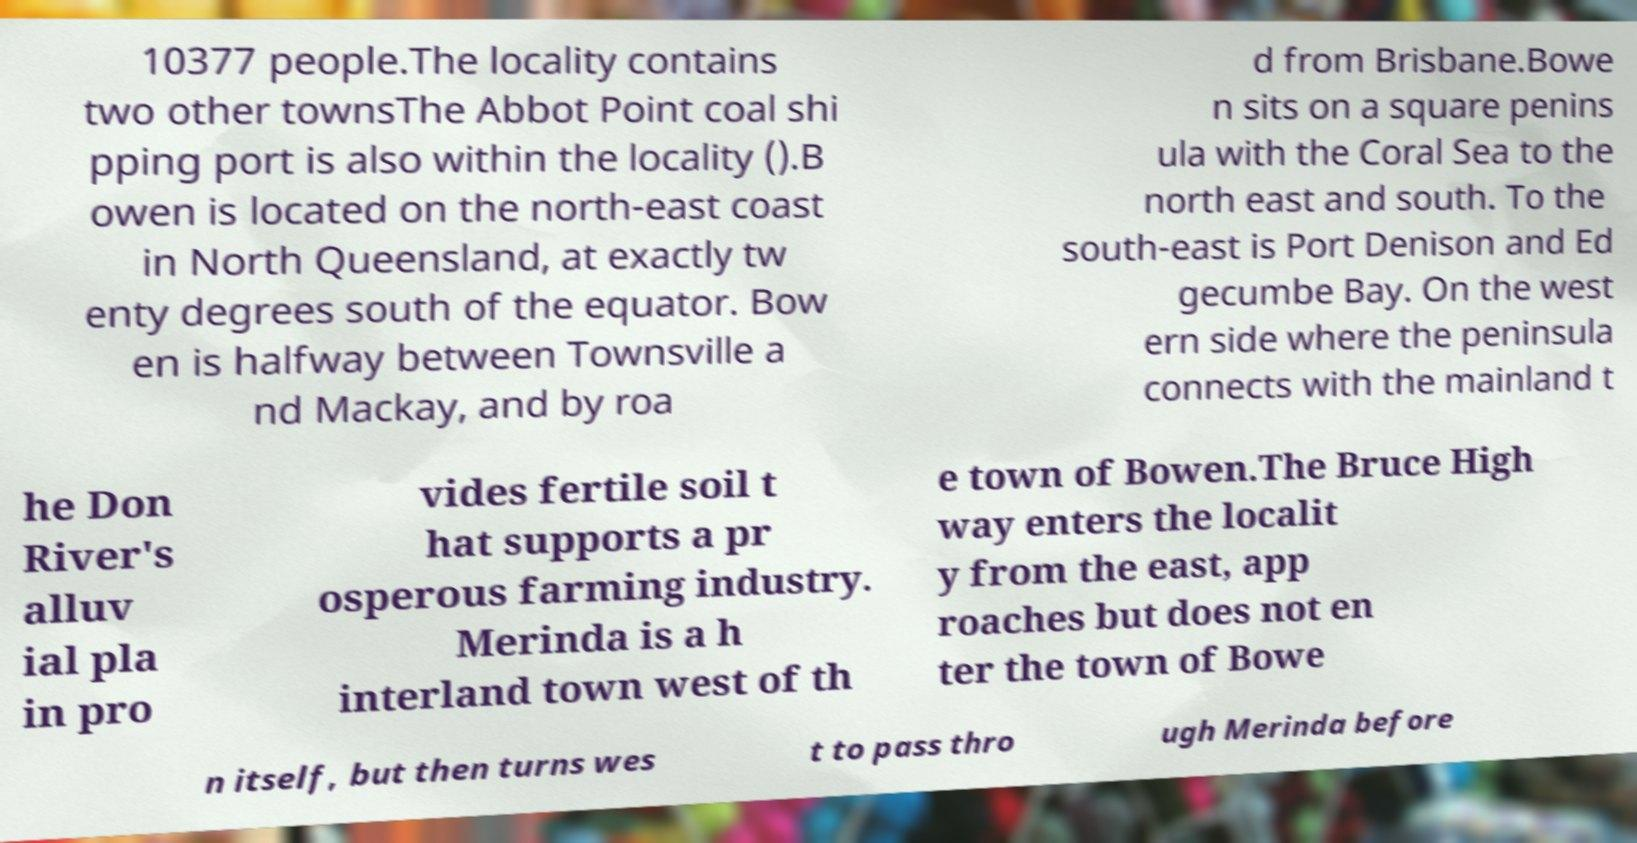Can you read and provide the text displayed in the image?This photo seems to have some interesting text. Can you extract and type it out for me? 10377 people.The locality contains two other townsThe Abbot Point coal shi pping port is also within the locality ().B owen is located on the north-east coast in North Queensland, at exactly tw enty degrees south of the equator. Bow en is halfway between Townsville a nd Mackay, and by roa d from Brisbane.Bowe n sits on a square penins ula with the Coral Sea to the north east and south. To the south-east is Port Denison and Ed gecumbe Bay. On the west ern side where the peninsula connects with the mainland t he Don River's alluv ial pla in pro vides fertile soil t hat supports a pr osperous farming industry. Merinda is a h interland town west of th e town of Bowen.The Bruce High way enters the localit y from the east, app roaches but does not en ter the town of Bowe n itself, but then turns wes t to pass thro ugh Merinda before 